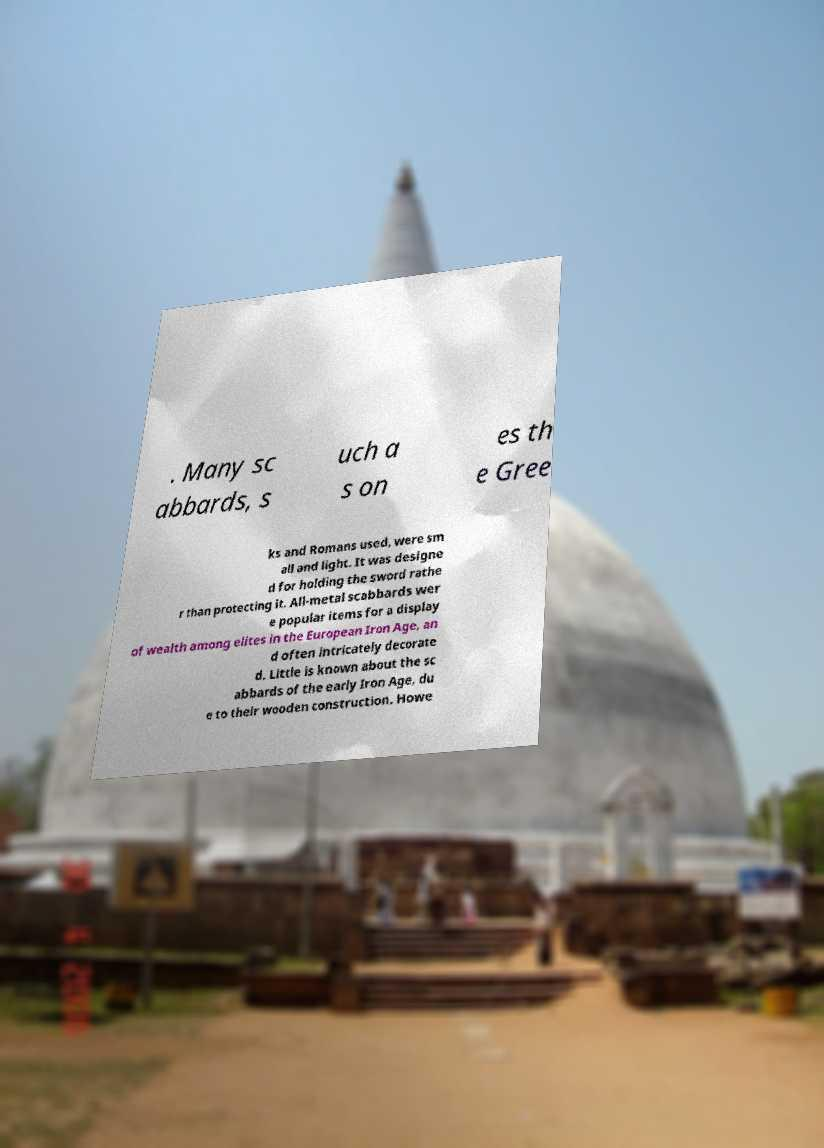Could you assist in decoding the text presented in this image and type it out clearly? . Many sc abbards, s uch a s on es th e Gree ks and Romans used, were sm all and light. It was designe d for holding the sword rathe r than protecting it. All-metal scabbards wer e popular items for a display of wealth among elites in the European Iron Age, an d often intricately decorate d. Little is known about the sc abbards of the early Iron Age, du e to their wooden construction. Howe 